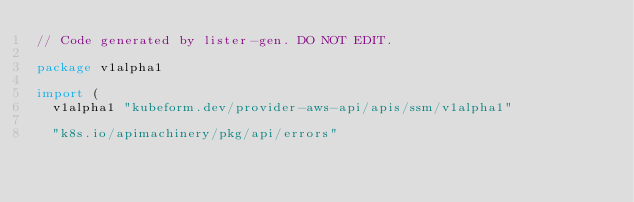Convert code to text. <code><loc_0><loc_0><loc_500><loc_500><_Go_>// Code generated by lister-gen. DO NOT EDIT.

package v1alpha1

import (
	v1alpha1 "kubeform.dev/provider-aws-api/apis/ssm/v1alpha1"

	"k8s.io/apimachinery/pkg/api/errors"</code> 